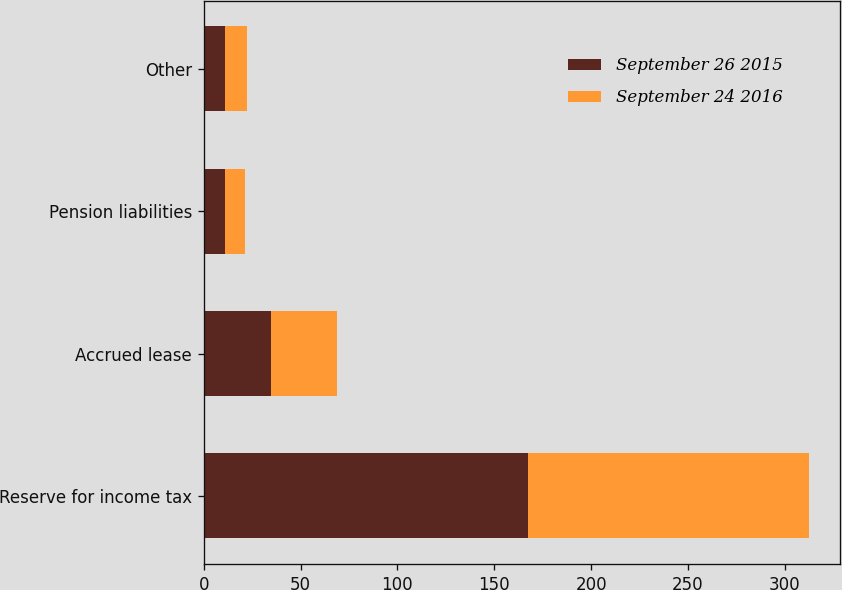Convert chart. <chart><loc_0><loc_0><loc_500><loc_500><stacked_bar_chart><ecel><fcel>Reserve for income tax<fcel>Accrued lease<fcel>Pension liabilities<fcel>Other<nl><fcel>September 26 2015<fcel>167.6<fcel>34.8<fcel>11.2<fcel>10.9<nl><fcel>September 24 2016<fcel>145.1<fcel>34<fcel>10.1<fcel>11.7<nl></chart> 